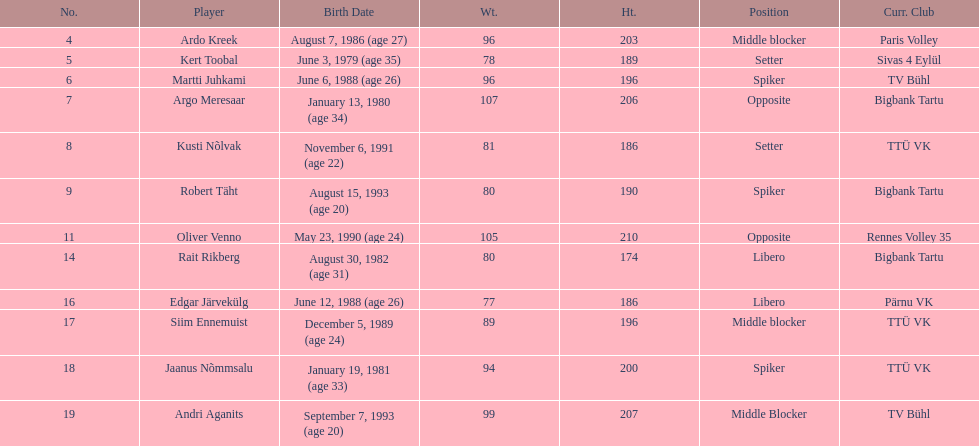How much taller in oliver venno than rait rikberg? 36. 